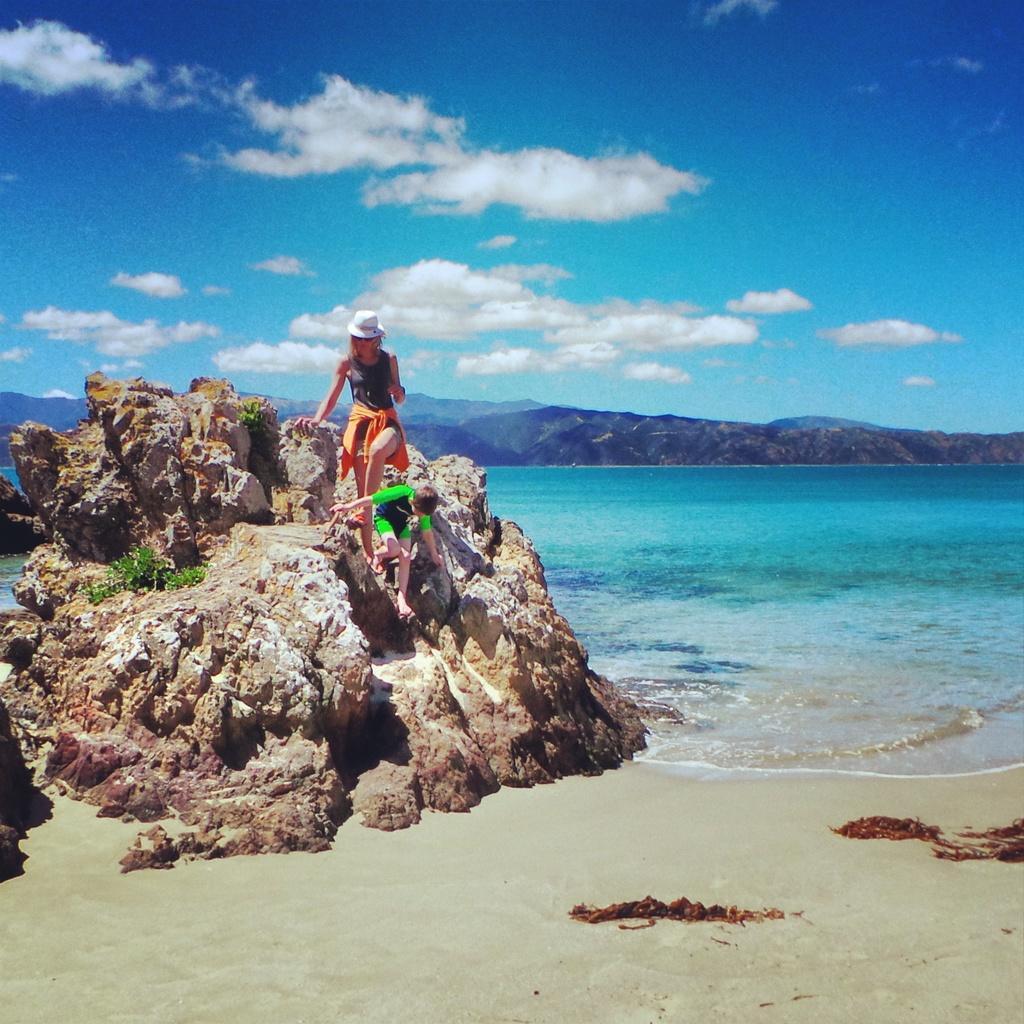How would you summarize this image in a sentence or two? In this image I can see two persons standing on the rock. In front the person is wearing blue and green color dress and the other person is wearing purple and orange color dress, background I can see the mountains and the sky is in blue and white color. 